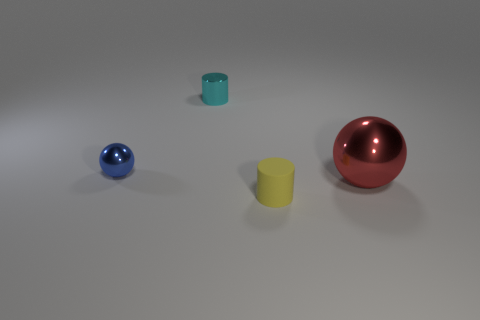Subtract all blue balls. How many balls are left? 1 Subtract 1 balls. How many balls are left? 1 Add 3 purple spheres. How many objects exist? 7 Add 2 cyan metal cylinders. How many cyan metal cylinders are left? 3 Add 1 big green rubber things. How many big green rubber things exist? 1 Subtract 1 cyan cylinders. How many objects are left? 3 Subtract all yellow matte cylinders. Subtract all large gray cylinders. How many objects are left? 3 